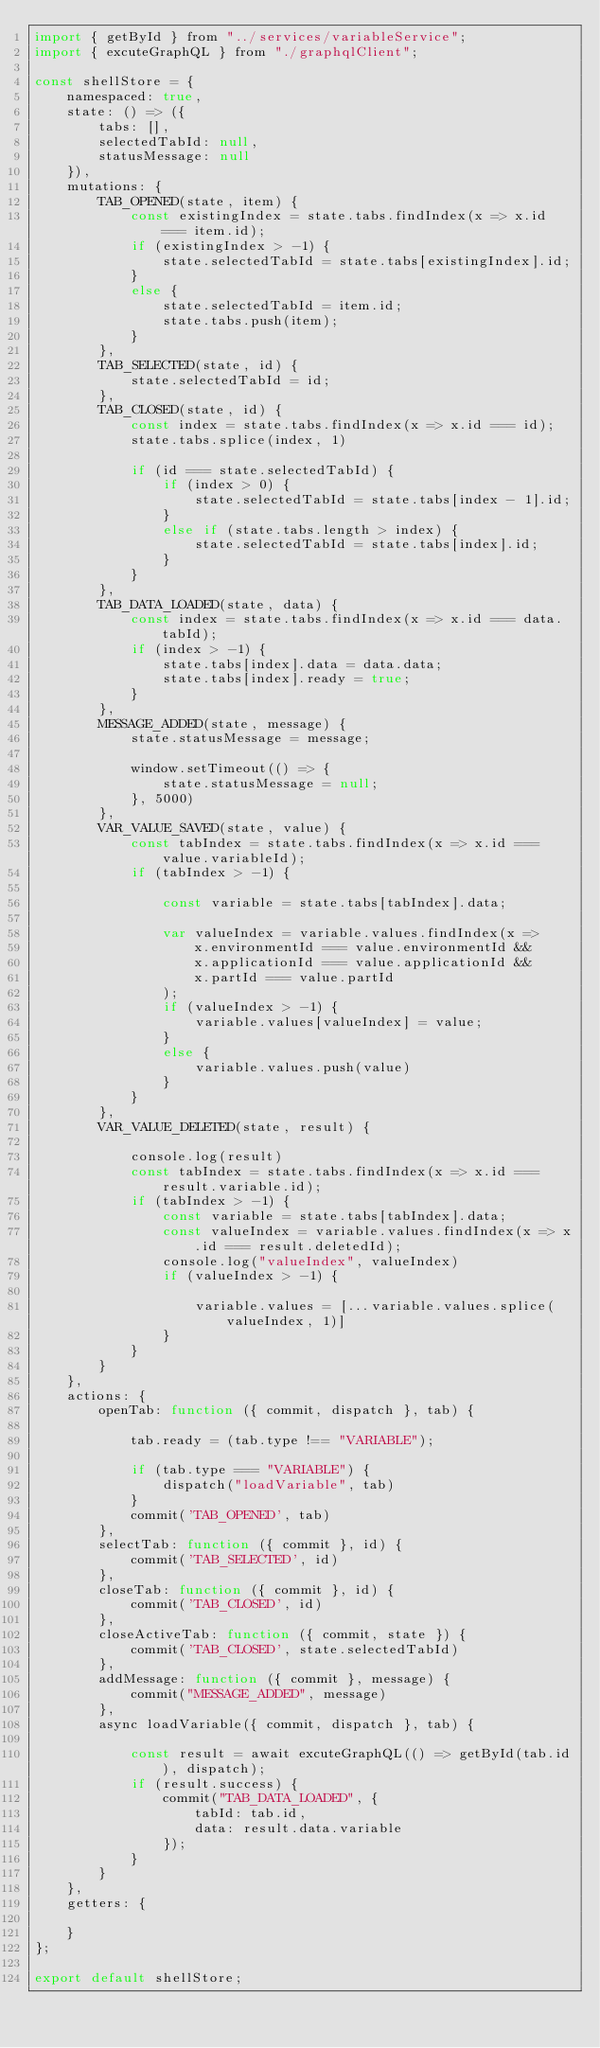Convert code to text. <code><loc_0><loc_0><loc_500><loc_500><_JavaScript_>import { getById } from "../services/variableService";
import { excuteGraphQL } from "./graphqlClient";

const shellStore = {
    namespaced: true,
    state: () => ({
        tabs: [],
        selectedTabId: null,
        statusMessage: null
    }),
    mutations: {
        TAB_OPENED(state, item) {
            const existingIndex = state.tabs.findIndex(x => x.id === item.id);
            if (existingIndex > -1) {
                state.selectedTabId = state.tabs[existingIndex].id;
            }
            else {
                state.selectedTabId = item.id;
                state.tabs.push(item);
            }
        },
        TAB_SELECTED(state, id) {
            state.selectedTabId = id;
        },
        TAB_CLOSED(state, id) {
            const index = state.tabs.findIndex(x => x.id === id);
            state.tabs.splice(index, 1)

            if (id === state.selectedTabId) {
                if (index > 0) {
                    state.selectedTabId = state.tabs[index - 1].id;
                }
                else if (state.tabs.length > index) {
                    state.selectedTabId = state.tabs[index].id;
                }
            }
        },
        TAB_DATA_LOADED(state, data) {
            const index = state.tabs.findIndex(x => x.id === data.tabId);
            if (index > -1) {
                state.tabs[index].data = data.data;
                state.tabs[index].ready = true;
            }
        },
        MESSAGE_ADDED(state, message) {
            state.statusMessage = message;

            window.setTimeout(() => {
                state.statusMessage = null;
            }, 5000)
        },
        VAR_VALUE_SAVED(state, value) {
            const tabIndex = state.tabs.findIndex(x => x.id === value.variableId);
            if (tabIndex > -1) {

                const variable = state.tabs[tabIndex].data;

                var valueIndex = variable.values.findIndex(x =>
                    x.environmentId === value.environmentId &&
                    x.applicationId === value.applicationId &&
                    x.partId === value.partId
                );
                if (valueIndex > -1) {
                    variable.values[valueIndex] = value;
                }
                else {
                    variable.values.push(value)
                }
            }
        },
        VAR_VALUE_DELETED(state, result) {

            console.log(result)
            const tabIndex = state.tabs.findIndex(x => x.id === result.variable.id);
            if (tabIndex > -1) {
                const variable = state.tabs[tabIndex].data;
                const valueIndex = variable.values.findIndex(x => x.id === result.deletedId);
                console.log("valueIndex", valueIndex)
                if (valueIndex > -1) {

                    variable.values = [...variable.values.splice(valueIndex, 1)]
                }
            }
        }
    },
    actions: {
        openTab: function ({ commit, dispatch }, tab) {

            tab.ready = (tab.type !== "VARIABLE");

            if (tab.type === "VARIABLE") {
                dispatch("loadVariable", tab)
            }
            commit('TAB_OPENED', tab)
        },
        selectTab: function ({ commit }, id) {
            commit('TAB_SELECTED', id)
        },
        closeTab: function ({ commit }, id) {
            commit('TAB_CLOSED', id)
        },
        closeActiveTab: function ({ commit, state }) {
            commit('TAB_CLOSED', state.selectedTabId)
        },
        addMessage: function ({ commit }, message) {
            commit("MESSAGE_ADDED", message)
        },
        async loadVariable({ commit, dispatch }, tab) {

            const result = await excuteGraphQL(() => getById(tab.id), dispatch);
            if (result.success) {
                commit("TAB_DATA_LOADED", {
                    tabId: tab.id,
                    data: result.data.variable
                });
            }
        }
    },
    getters: {

    }
};

export default shellStore;
</code> 